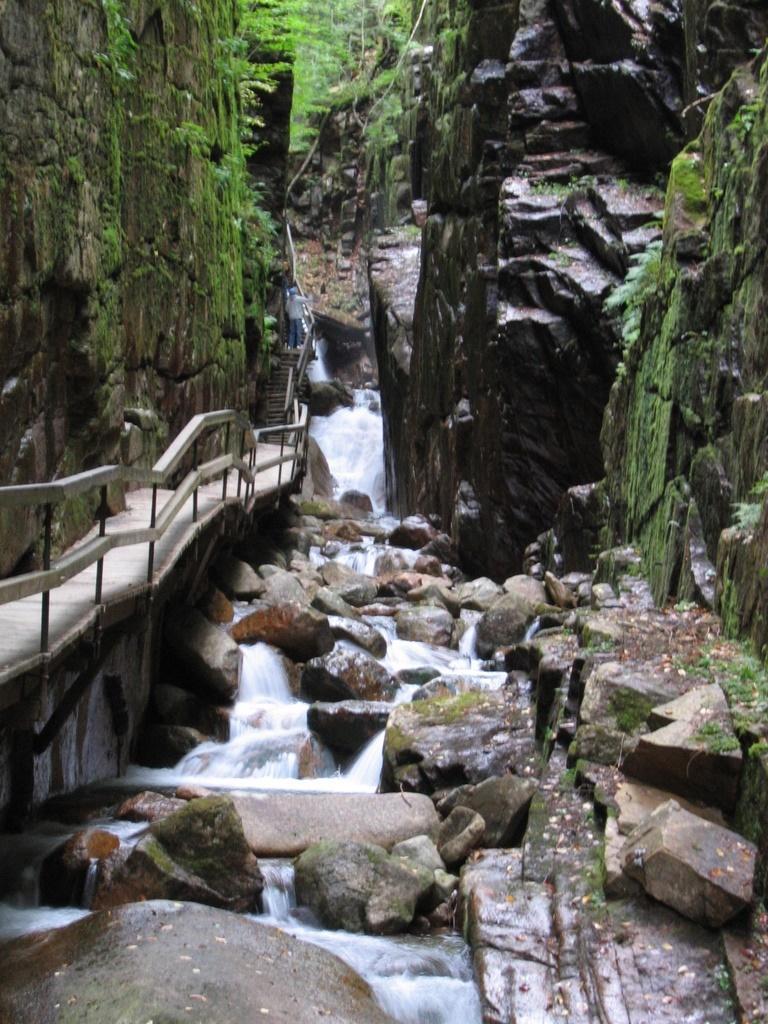Could you give a brief overview of what you see in this image? In this image I can see the waterfall, background I can see few stones, a bridge and trees in green color. 